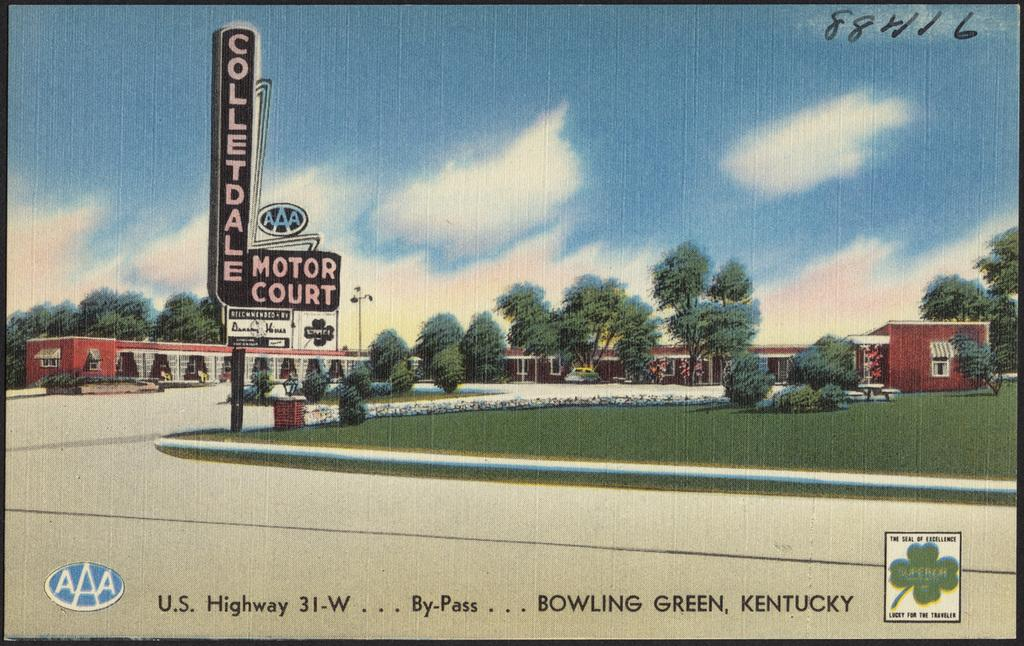<image>
Summarize the visual content of the image. A postcard featuring a drawn image of Colletdale Motor Courk in Kentucky. 